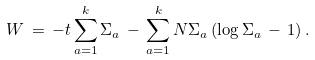<formula> <loc_0><loc_0><loc_500><loc_500>W \, = \, - t \sum _ { a = 1 } ^ { k } \Sigma _ { a } \, - \, \sum _ { a = 1 } ^ { k } N \Sigma _ { a } \left ( \log \Sigma _ { a } \, - \, 1 \right ) .</formula> 